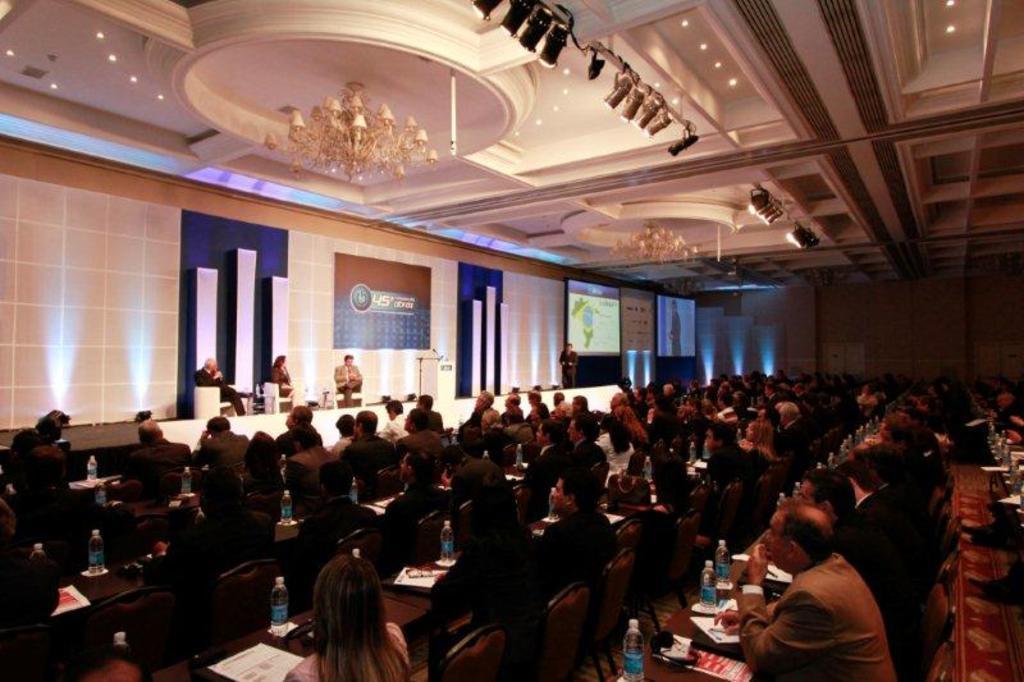Could you give a brief overview of what you see in this image? In this image few persons are sitting on the chairs. Before them there are few tables. On it there are bottles and papers. Three persons are sitting on the stage. Middle of the image there is a person standing on the stage. Few lights are attached to the roof. Two screens and a banner are attached to the wall. 